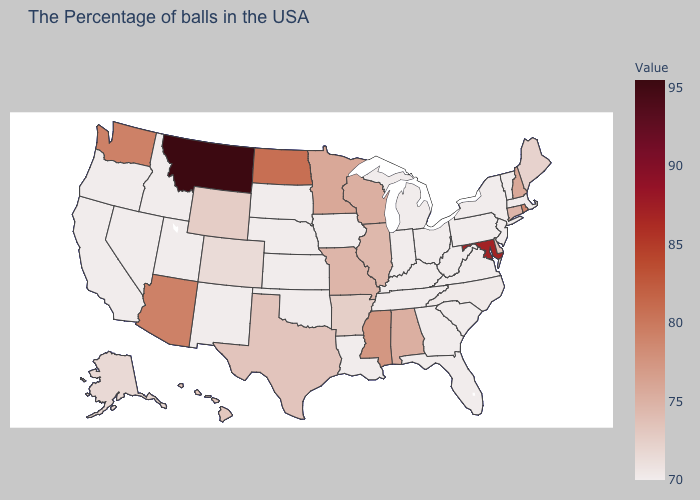Does Connecticut have a higher value than Oklahoma?
Give a very brief answer. Yes. Does Montana have the highest value in the West?
Answer briefly. Yes. Does the map have missing data?
Concise answer only. No. Among the states that border Missouri , does Arkansas have the lowest value?
Give a very brief answer. No. Does the map have missing data?
Write a very short answer. No. Is the legend a continuous bar?
Give a very brief answer. Yes. Which states have the lowest value in the USA?
Answer briefly. Massachusetts, Vermont, New York, New Jersey, Pennsylvania, Virginia, South Carolina, West Virginia, Ohio, Florida, Georgia, Michigan, Kentucky, Indiana, Tennessee, Louisiana, Iowa, Kansas, Nebraska, Oklahoma, South Dakota, New Mexico, Utah, Idaho, Nevada, California, Oregon. Does North Dakota have the highest value in the MidWest?
Answer briefly. Yes. 